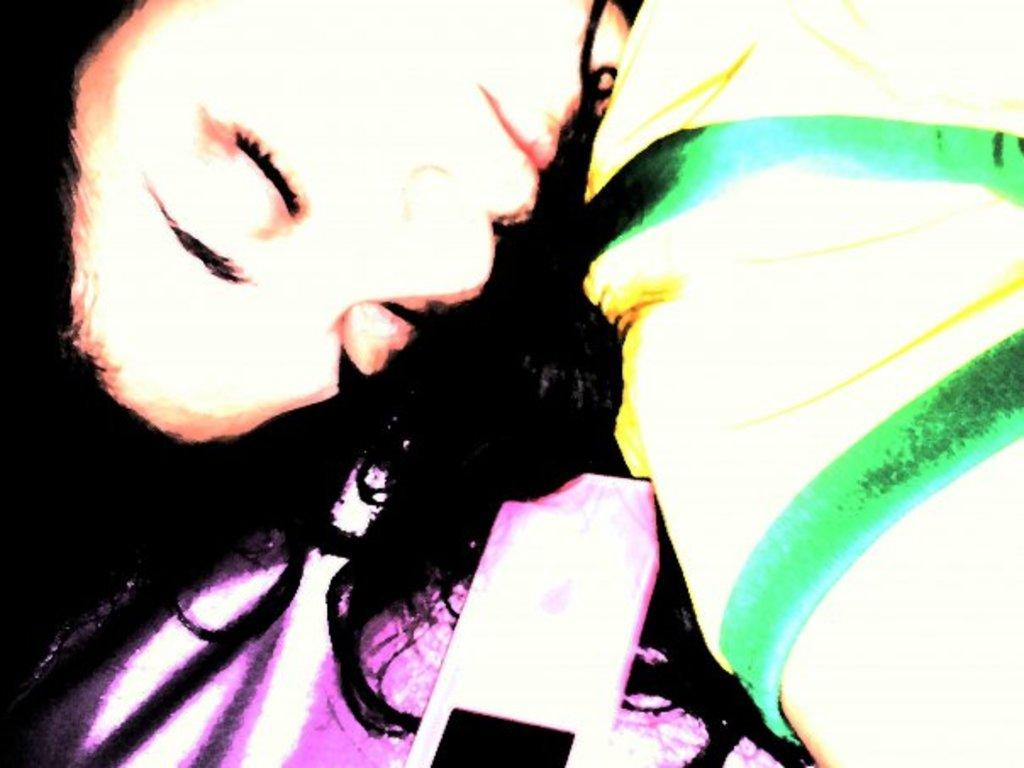What is the main subject of the image? There is a person in the image. What else can be seen in the image besides the person? There is a mobile in the image. What type of agreement is being discussed in the image? There is no indication of any agreement being discussed in the image, as it only features a person and a mobile. How many baseballs can be seen in the image? There are no baseballs present in the image. 